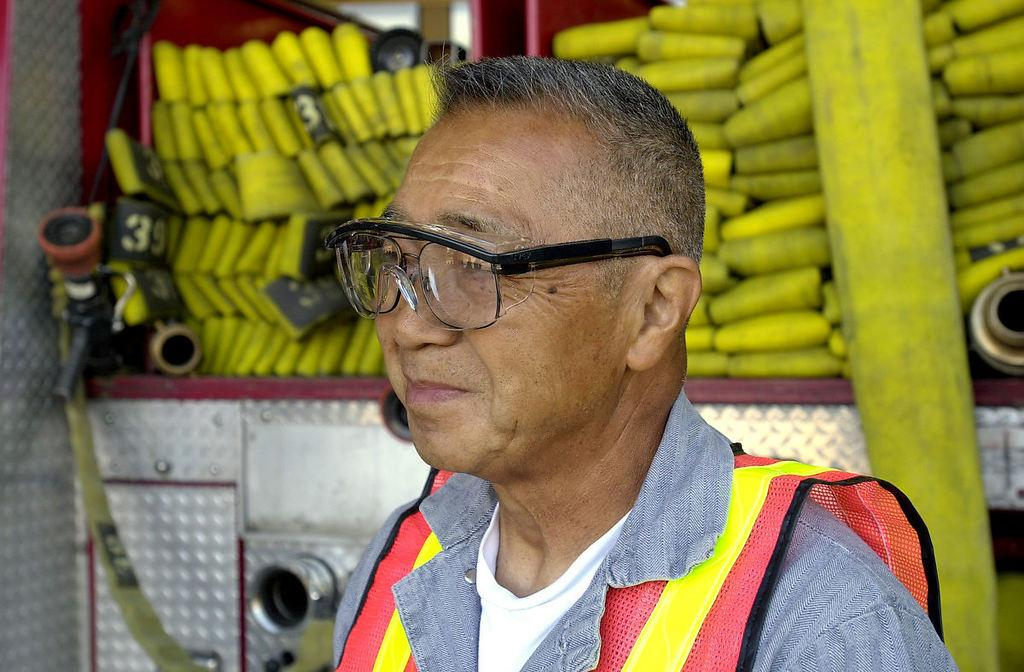Who or what is present in the image? There is a person in the image. What is the person doing or expressing? The person is smiling. What can be seen behind the person? There is a fire truck behind the person. What specific features can be observed on the fire truck? Water pipes are visible on the fire truck. How many birds are sitting on the glass in the image? There are no birds or glass present in the image. 